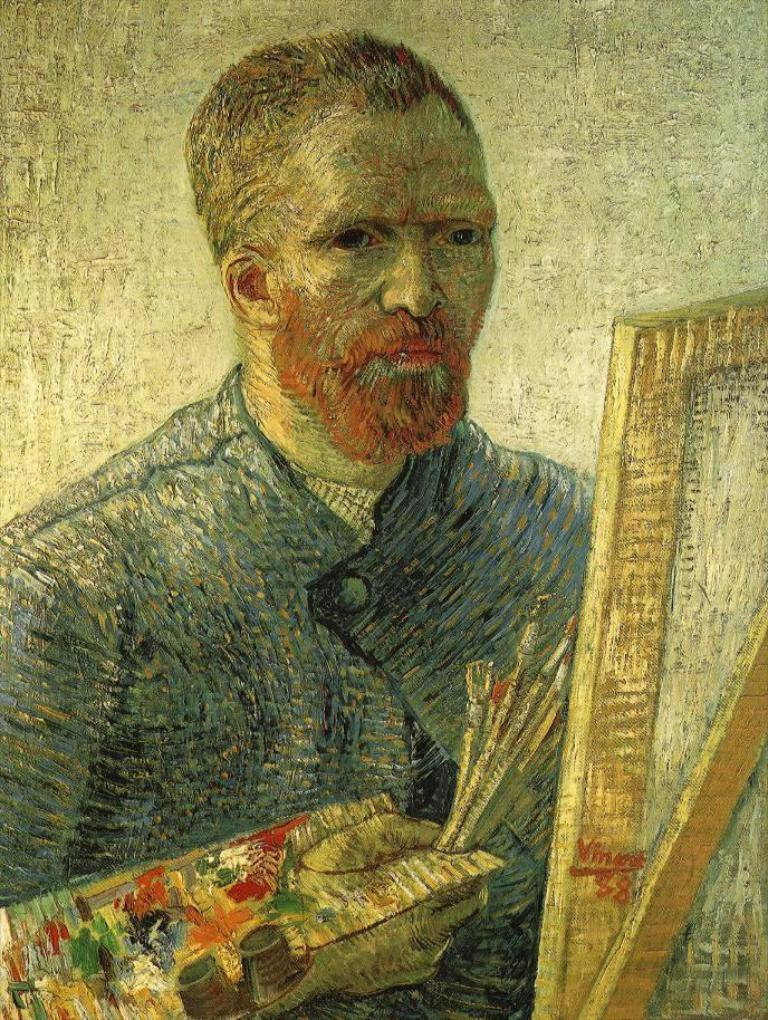What is the main subject of the image? There is a painting in the image. What does the painting depict? The painting depicts a person. Are there any other elements in the painting besides the person? Yes, there are other objects present in the painting. What type of mask is the person wearing in the painting? There is no mask present in the painting; it depicts a person without any mask. How many trains can be seen in the painting? There are no trains present in the painting; it only depicts a person and other objects. 